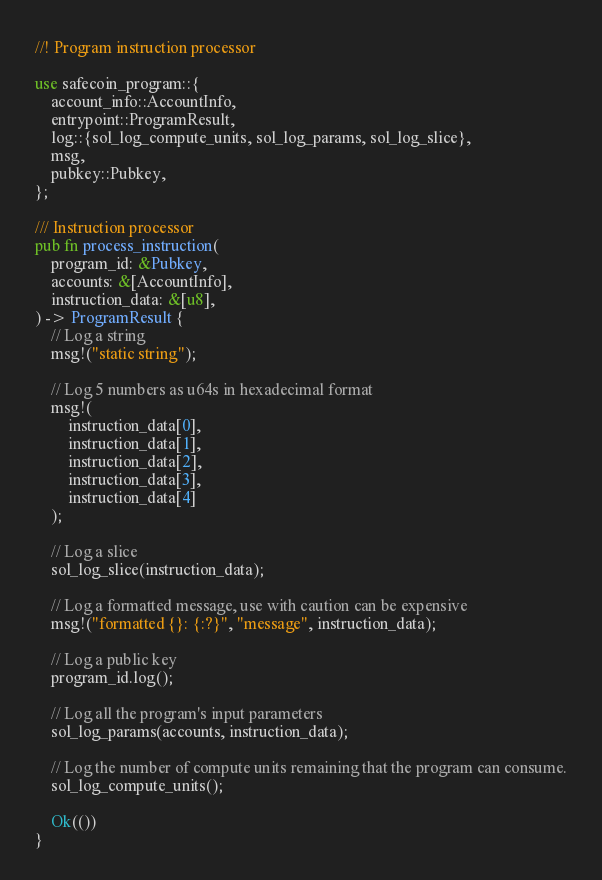Convert code to text. <code><loc_0><loc_0><loc_500><loc_500><_Rust_>//! Program instruction processor

use safecoin_program::{
    account_info::AccountInfo,
    entrypoint::ProgramResult,
    log::{sol_log_compute_units, sol_log_params, sol_log_slice},
    msg,
    pubkey::Pubkey,
};

/// Instruction processor
pub fn process_instruction(
    program_id: &Pubkey,
    accounts: &[AccountInfo],
    instruction_data: &[u8],
) -> ProgramResult {
    // Log a string
    msg!("static string");

    // Log 5 numbers as u64s in hexadecimal format
    msg!(
        instruction_data[0],
        instruction_data[1],
        instruction_data[2],
        instruction_data[3],
        instruction_data[4]
    );

    // Log a slice
    sol_log_slice(instruction_data);

    // Log a formatted message, use with caution can be expensive
    msg!("formatted {}: {:?}", "message", instruction_data);

    // Log a public key
    program_id.log();

    // Log all the program's input parameters
    sol_log_params(accounts, instruction_data);

    // Log the number of compute units remaining that the program can consume.
    sol_log_compute_units();

    Ok(())
}
</code> 